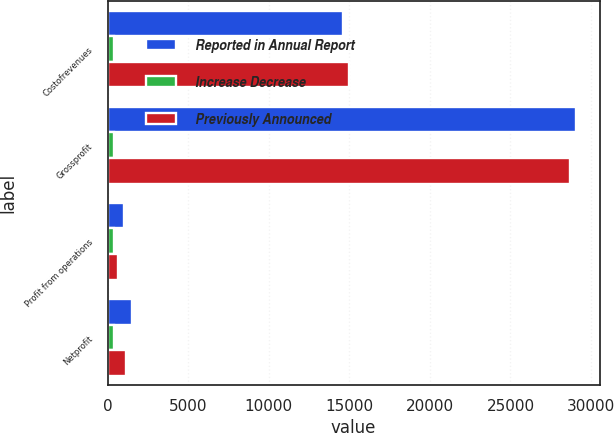Convert chart. <chart><loc_0><loc_0><loc_500><loc_500><stacked_bar_chart><ecel><fcel>Costofrevenues<fcel>Grossprofit<fcel>Profit from operations<fcel>Netprofit<nl><fcel>Reported in Annual Report<fcel>14578<fcel>29077<fcel>1039<fcel>1504<nl><fcel>Increase Decrease<fcel>383<fcel>383<fcel>383<fcel>383<nl><fcel>Previously Announced<fcel>14961<fcel>28694<fcel>656<fcel>1121<nl></chart> 